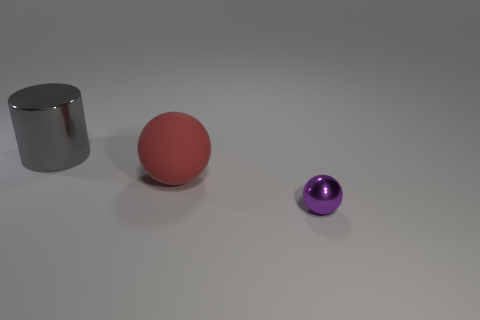There is a purple metal thing; is it the same size as the ball behind the tiny purple ball?
Your response must be concise. No. Are there any shiny balls that have the same color as the matte ball?
Ensure brevity in your answer.  No. Is there a large gray thing of the same shape as the purple metal object?
Keep it short and to the point. No. What shape is the object that is in front of the big gray cylinder and on the left side of the small purple object?
Your answer should be compact. Sphere. How many tiny purple balls are the same material as the gray object?
Ensure brevity in your answer.  1. Are there fewer large red things in front of the red matte object than big gray metallic cylinders?
Your answer should be compact. Yes. Is there a metal ball that is on the right side of the sphere behind the purple metallic ball?
Your answer should be compact. Yes. Are there any other things that are the same shape as the purple metallic object?
Ensure brevity in your answer.  Yes. Is the matte ball the same size as the purple metallic sphere?
Make the answer very short. No. There is a big object that is to the right of the shiny object behind the ball that is in front of the large red matte ball; what is it made of?
Your response must be concise. Rubber. 